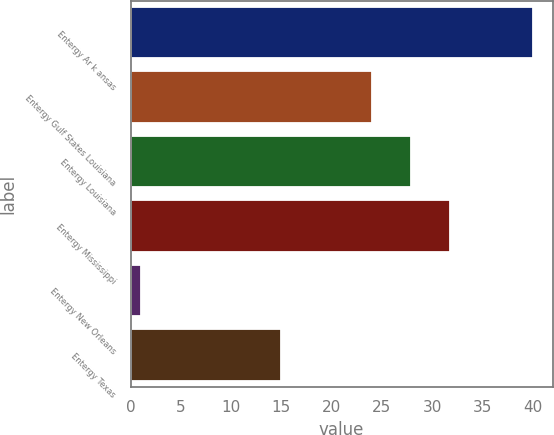Convert chart to OTSL. <chart><loc_0><loc_0><loc_500><loc_500><bar_chart><fcel>Entergy Ar k ansas<fcel>Entergy Gulf States Louisiana<fcel>Entergy Louisiana<fcel>Entergy Mississippi<fcel>Entergy New Orleans<fcel>Entergy Texas<nl><fcel>40<fcel>24<fcel>27.9<fcel>31.8<fcel>1<fcel>15<nl></chart> 